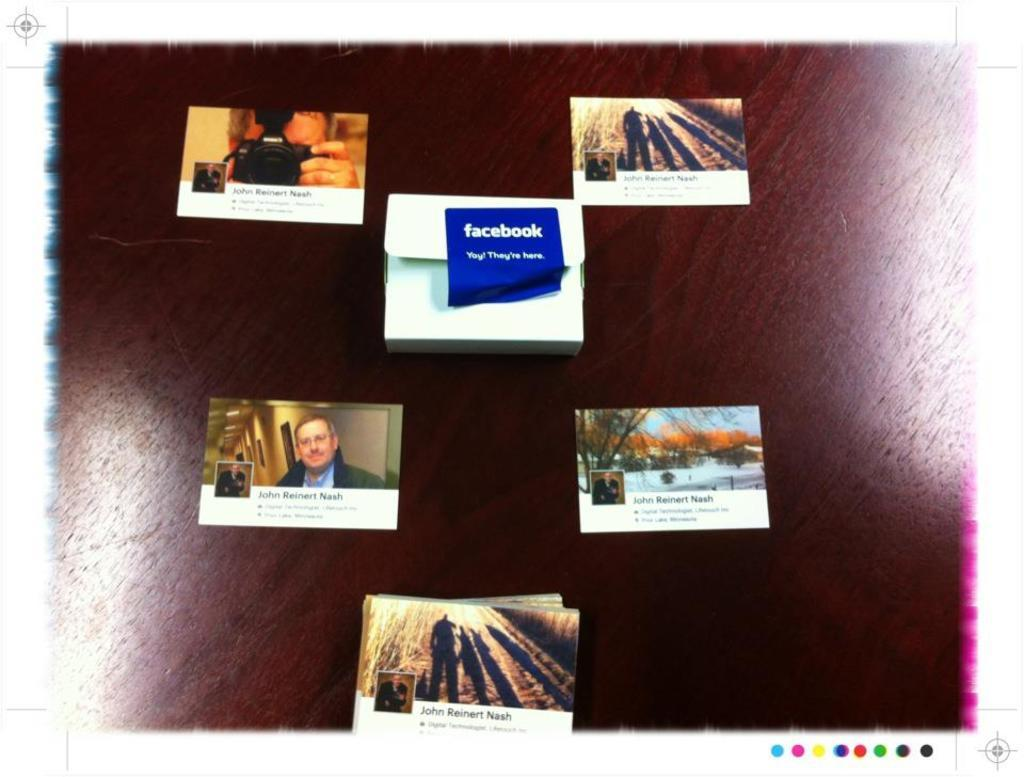<image>
Create a compact narrative representing the image presented. Five business cards featuring the works of photographer John Reinert Nash and an envelope from  Facebook that says They are here. 